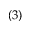Convert formula to latex. <formula><loc_0><loc_0><loc_500><loc_500>( 3 )</formula> 